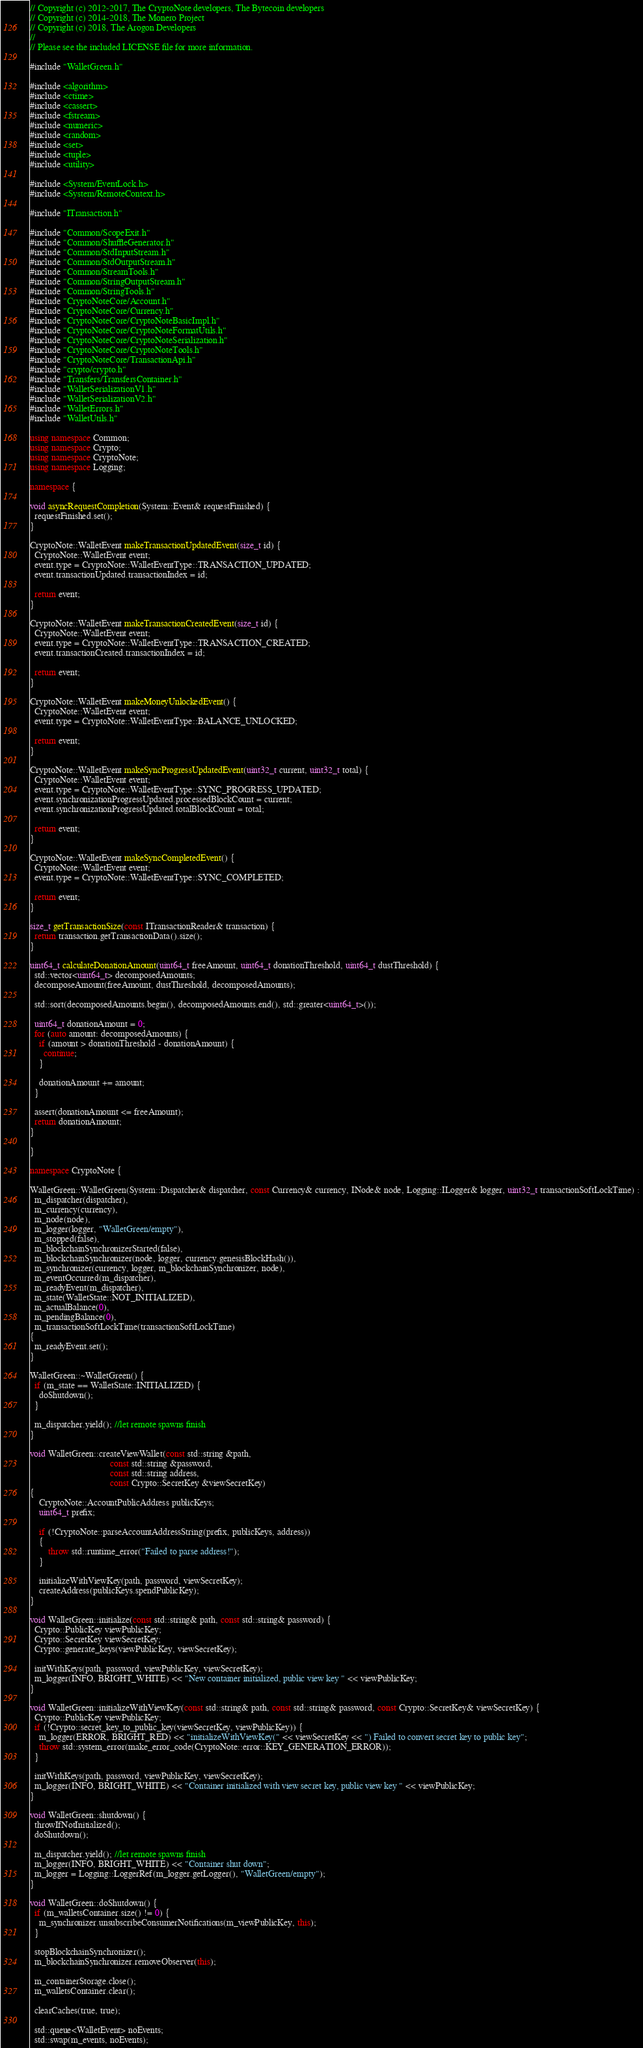Convert code to text. <code><loc_0><loc_0><loc_500><loc_500><_C++_>// Copyright (c) 2012-2017, The CryptoNote developers, The Bytecoin developers
// Copyright (c) 2014-2018, The Monero Project
// Copyright (c) 2018, The Arogon Developers
// 
// Please see the included LICENSE file for more information.

#include "WalletGreen.h"

#include <algorithm>
#include <ctime>
#include <cassert>
#include <fstream>
#include <numeric>
#include <random>
#include <set>
#include <tuple>
#include <utility>

#include <System/EventLock.h>
#include <System/RemoteContext.h>

#include "ITransaction.h"

#include "Common/ScopeExit.h"
#include "Common/ShuffleGenerator.h"
#include "Common/StdInputStream.h"
#include "Common/StdOutputStream.h"
#include "Common/StreamTools.h"
#include "Common/StringOutputStream.h"
#include "Common/StringTools.h"
#include "CryptoNoteCore/Account.h"
#include "CryptoNoteCore/Currency.h"
#include "CryptoNoteCore/CryptoNoteBasicImpl.h"
#include "CryptoNoteCore/CryptoNoteFormatUtils.h"
#include "CryptoNoteCore/CryptoNoteSerialization.h"
#include "CryptoNoteCore/CryptoNoteTools.h"
#include "CryptoNoteCore/TransactionApi.h"
#include "crypto/crypto.h"
#include "Transfers/TransfersContainer.h"
#include "WalletSerializationV1.h"
#include "WalletSerializationV2.h"
#include "WalletErrors.h"
#include "WalletUtils.h"

using namespace Common;
using namespace Crypto;
using namespace CryptoNote;
using namespace Logging;

namespace {

void asyncRequestCompletion(System::Event& requestFinished) {
  requestFinished.set();
}

CryptoNote::WalletEvent makeTransactionUpdatedEvent(size_t id) {
  CryptoNote::WalletEvent event;
  event.type = CryptoNote::WalletEventType::TRANSACTION_UPDATED;
  event.transactionUpdated.transactionIndex = id;

  return event;
}

CryptoNote::WalletEvent makeTransactionCreatedEvent(size_t id) {
  CryptoNote::WalletEvent event;
  event.type = CryptoNote::WalletEventType::TRANSACTION_CREATED;
  event.transactionCreated.transactionIndex = id;

  return event;
}

CryptoNote::WalletEvent makeMoneyUnlockedEvent() {
  CryptoNote::WalletEvent event;
  event.type = CryptoNote::WalletEventType::BALANCE_UNLOCKED;

  return event;
}

CryptoNote::WalletEvent makeSyncProgressUpdatedEvent(uint32_t current, uint32_t total) {
  CryptoNote::WalletEvent event;
  event.type = CryptoNote::WalletEventType::SYNC_PROGRESS_UPDATED;
  event.synchronizationProgressUpdated.processedBlockCount = current;
  event.synchronizationProgressUpdated.totalBlockCount = total;

  return event;
}

CryptoNote::WalletEvent makeSyncCompletedEvent() {
  CryptoNote::WalletEvent event;
  event.type = CryptoNote::WalletEventType::SYNC_COMPLETED;

  return event;
}

size_t getTransactionSize(const ITransactionReader& transaction) {
  return transaction.getTransactionData().size();
}

uint64_t calculateDonationAmount(uint64_t freeAmount, uint64_t donationThreshold, uint64_t dustThreshold) {
  std::vector<uint64_t> decomposedAmounts;
  decomposeAmount(freeAmount, dustThreshold, decomposedAmounts);

  std::sort(decomposedAmounts.begin(), decomposedAmounts.end(), std::greater<uint64_t>());

  uint64_t donationAmount = 0;
  for (auto amount: decomposedAmounts) {
    if (amount > donationThreshold - donationAmount) {
      continue;
    }

    donationAmount += amount;
  }

  assert(donationAmount <= freeAmount);
  return donationAmount;
}

}

namespace CryptoNote {

WalletGreen::WalletGreen(System::Dispatcher& dispatcher, const Currency& currency, INode& node, Logging::ILogger& logger, uint32_t transactionSoftLockTime) :
  m_dispatcher(dispatcher),
  m_currency(currency),
  m_node(node),
  m_logger(logger, "WalletGreen/empty"),
  m_stopped(false),
  m_blockchainSynchronizerStarted(false),
  m_blockchainSynchronizer(node, logger, currency.genesisBlockHash()),
  m_synchronizer(currency, logger, m_blockchainSynchronizer, node),
  m_eventOccurred(m_dispatcher),
  m_readyEvent(m_dispatcher),
  m_state(WalletState::NOT_INITIALIZED),
  m_actualBalance(0),
  m_pendingBalance(0),
  m_transactionSoftLockTime(transactionSoftLockTime)
{
  m_readyEvent.set();
}

WalletGreen::~WalletGreen() {
  if (m_state == WalletState::INITIALIZED) {
    doShutdown();
  }

  m_dispatcher.yield(); //let remote spawns finish
}

void WalletGreen::createViewWallet(const std::string &path,
                                   const std::string &password,
                                   const std::string address,
                                   const Crypto::SecretKey &viewSecretKey)
{
    CryptoNote::AccountPublicAddress publicKeys;
    uint64_t prefix;

    if (!CryptoNote::parseAccountAddressString(prefix, publicKeys, address))
    {
        throw std::runtime_error("Failed to parse address!");
    }

    initializeWithViewKey(path, password, viewSecretKey);
    createAddress(publicKeys.spendPublicKey);
}

void WalletGreen::initialize(const std::string& path, const std::string& password) {
  Crypto::PublicKey viewPublicKey;
  Crypto::SecretKey viewSecretKey;
  Crypto::generate_keys(viewPublicKey, viewSecretKey);

  initWithKeys(path, password, viewPublicKey, viewSecretKey);
  m_logger(INFO, BRIGHT_WHITE) << "New container initialized, public view key " << viewPublicKey;
}

void WalletGreen::initializeWithViewKey(const std::string& path, const std::string& password, const Crypto::SecretKey& viewSecretKey) {
  Crypto::PublicKey viewPublicKey;
  if (!Crypto::secret_key_to_public_key(viewSecretKey, viewPublicKey)) {
    m_logger(ERROR, BRIGHT_RED) << "initializeWithViewKey(" << viewSecretKey << ") Failed to convert secret key to public key";
    throw std::system_error(make_error_code(CryptoNote::error::KEY_GENERATION_ERROR));
  }

  initWithKeys(path, password, viewPublicKey, viewSecretKey);
  m_logger(INFO, BRIGHT_WHITE) << "Container initialized with view secret key, public view key " << viewPublicKey;
}

void WalletGreen::shutdown() {
  throwIfNotInitialized();
  doShutdown();

  m_dispatcher.yield(); //let remote spawns finish
  m_logger(INFO, BRIGHT_WHITE) << "Container shut down";
  m_logger = Logging::LoggerRef(m_logger.getLogger(), "WalletGreen/empty");
}

void WalletGreen::doShutdown() {
  if (m_walletsContainer.size() != 0) {
    m_synchronizer.unsubscribeConsumerNotifications(m_viewPublicKey, this);
  }

  stopBlockchainSynchronizer();
  m_blockchainSynchronizer.removeObserver(this);

  m_containerStorage.close();
  m_walletsContainer.clear();

  clearCaches(true, true);

  std::queue<WalletEvent> noEvents;
  std::swap(m_events, noEvents);
</code> 